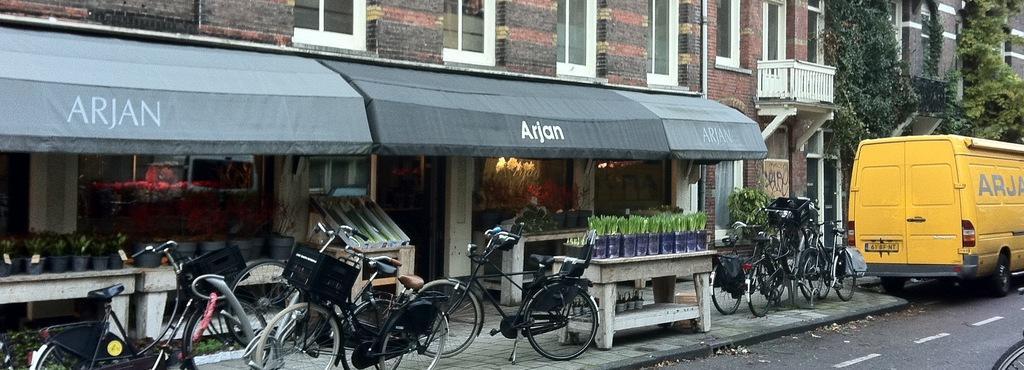Describe this image in one or two sentences. In the image we can see a building and the windows of the building, there are even bicycles and a vehicle. There is a road and white lines on the road, plant, and footpath. 